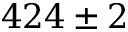Convert formula to latex. <formula><loc_0><loc_0><loc_500><loc_500>4 2 4 \pm 2</formula> 